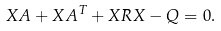Convert formula to latex. <formula><loc_0><loc_0><loc_500><loc_500>X A + X A ^ { T } + X R X - Q = 0 .</formula> 